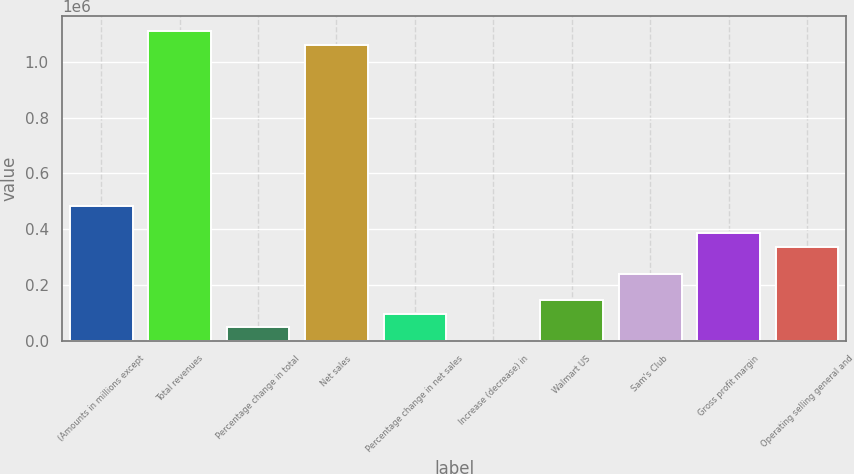Convert chart. <chart><loc_0><loc_0><loc_500><loc_500><bar_chart><fcel>(Amounts in millions except<fcel>Total revenues<fcel>Percentage change in total<fcel>Net sales<fcel>Percentage change in net sales<fcel>Increase (decrease) in<fcel>Walmart US<fcel>Sam's Club<fcel>Gross profit margin<fcel>Operating selling general and<nl><fcel>482130<fcel>1.1089e+06<fcel>48213.3<fcel>1.06069e+06<fcel>96426.2<fcel>0.3<fcel>144639<fcel>241065<fcel>385704<fcel>337491<nl></chart> 